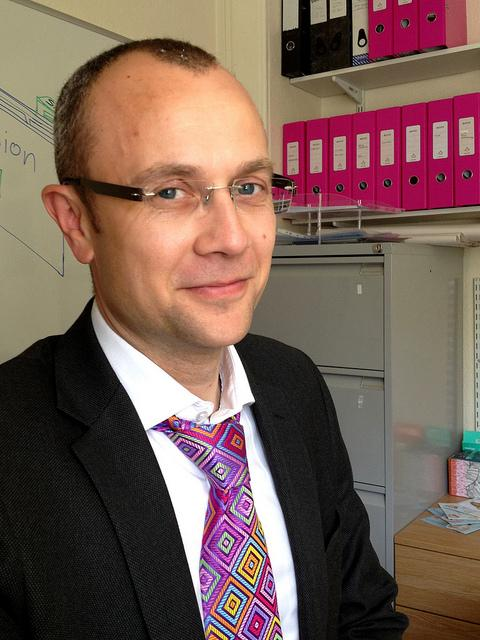What are the pink objects on the shelf?

Choices:
A) boxes
B) envelopes
C) hard drives
D) binders binders 